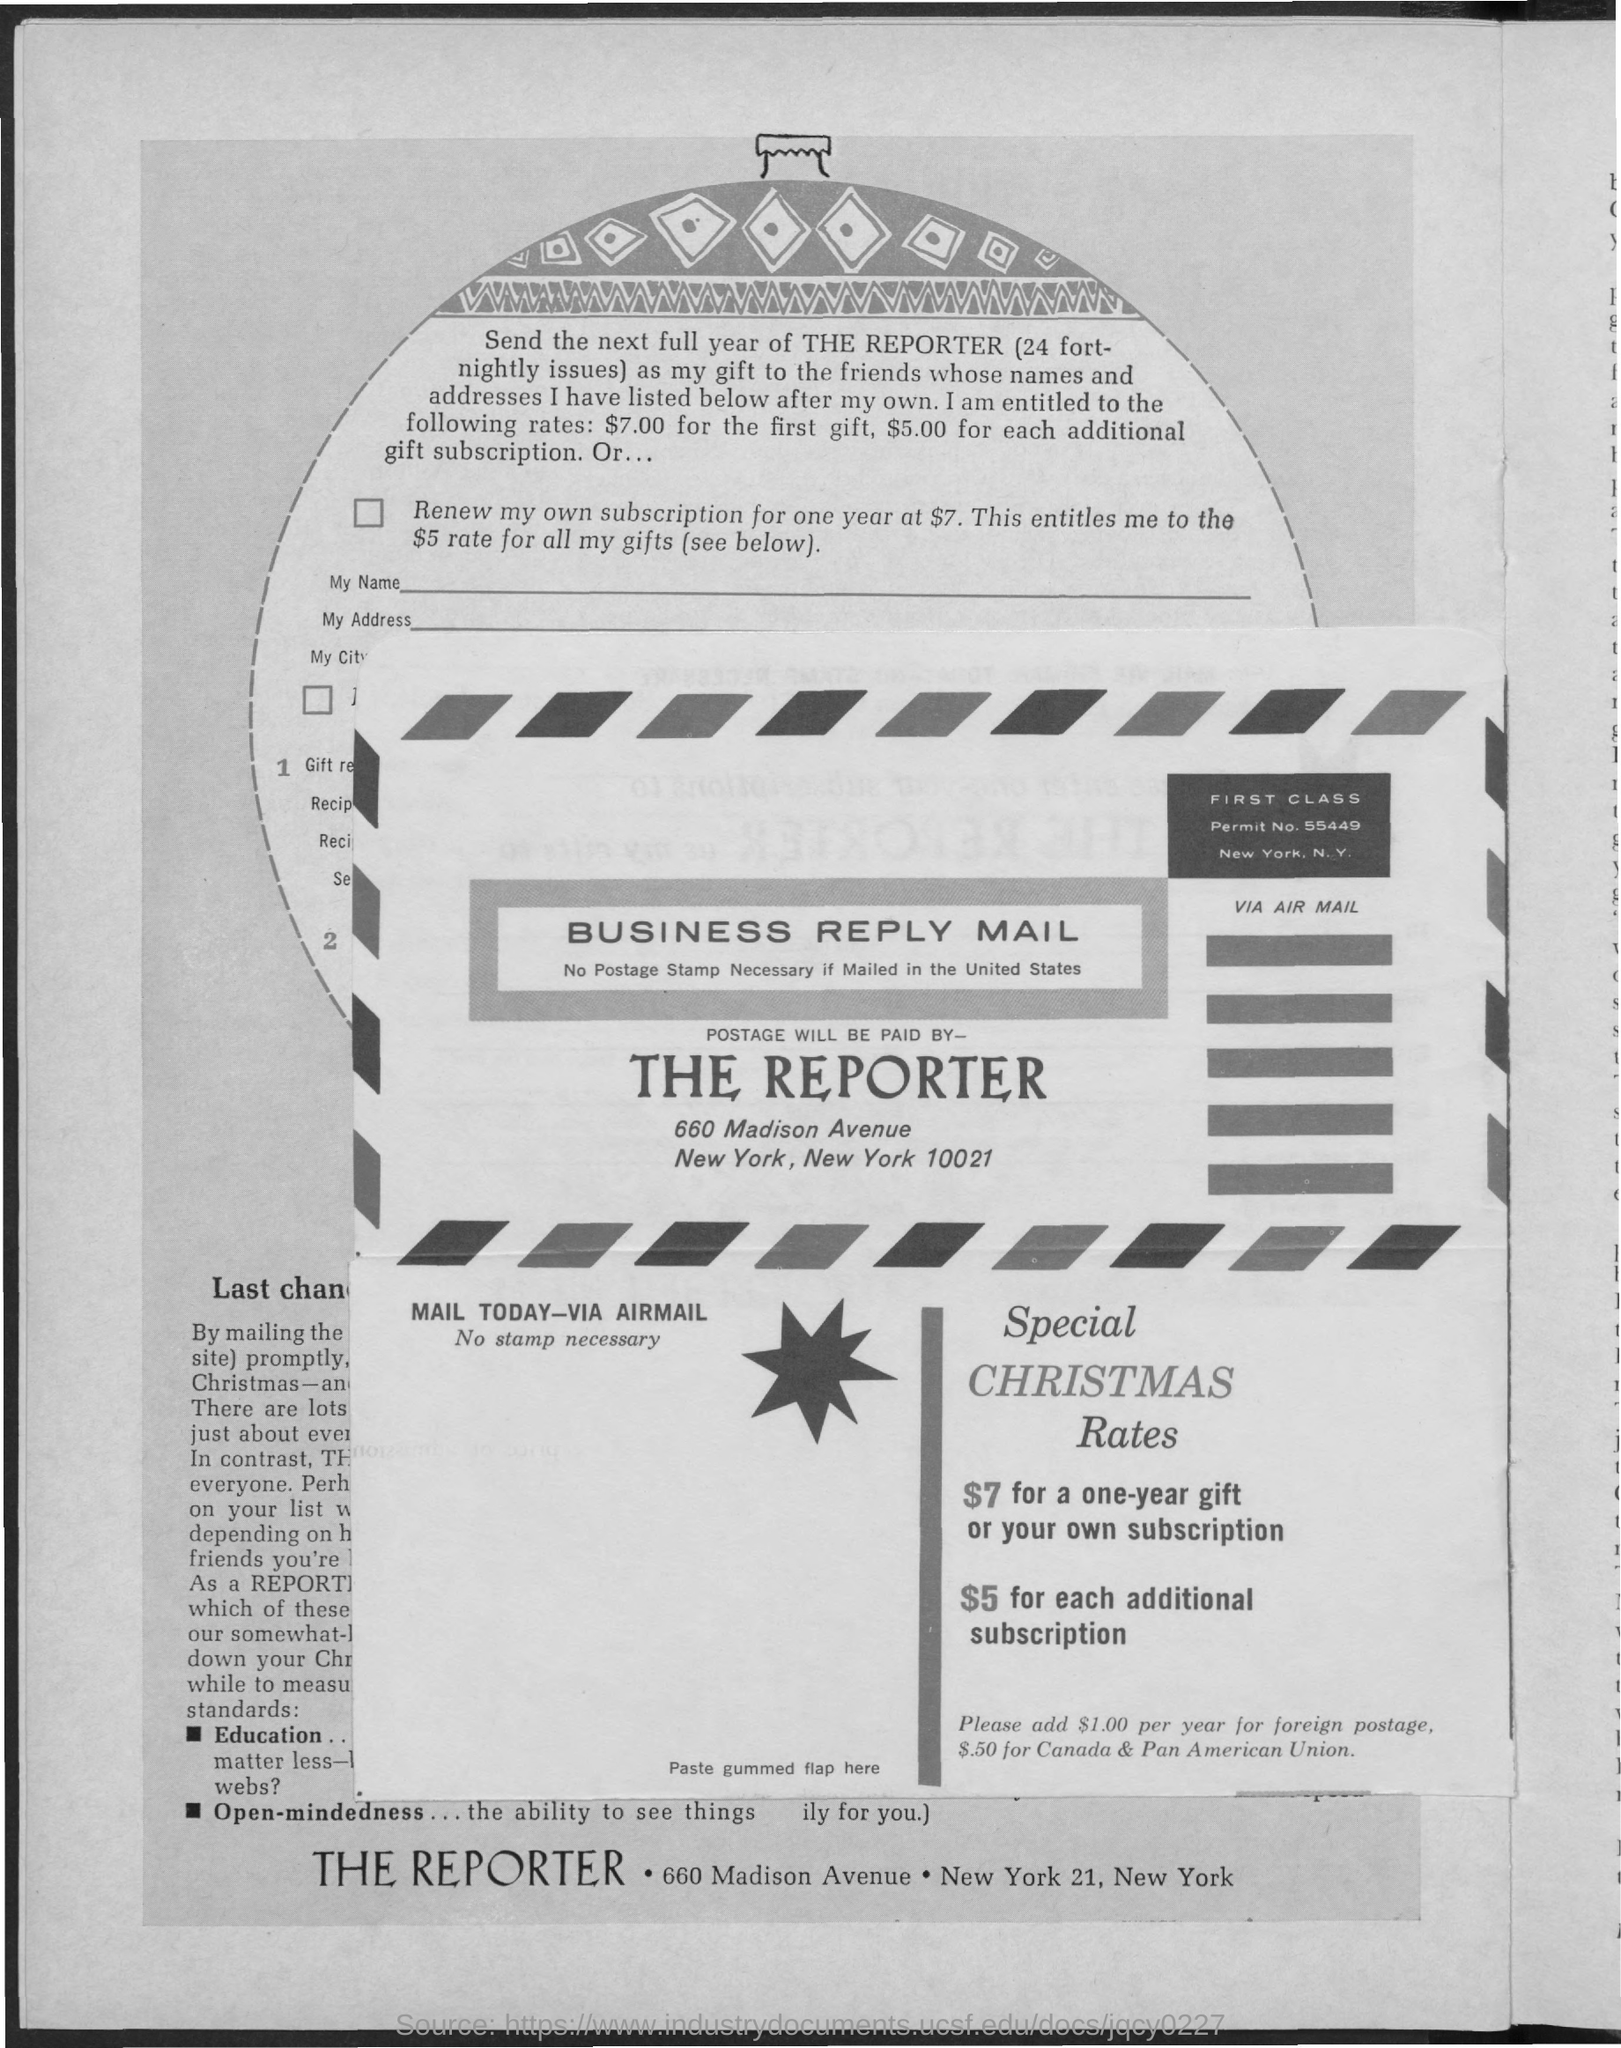List a handful of essential elements in this visual. The permit number is 55449. The reporter is responsible for paying the postage. 